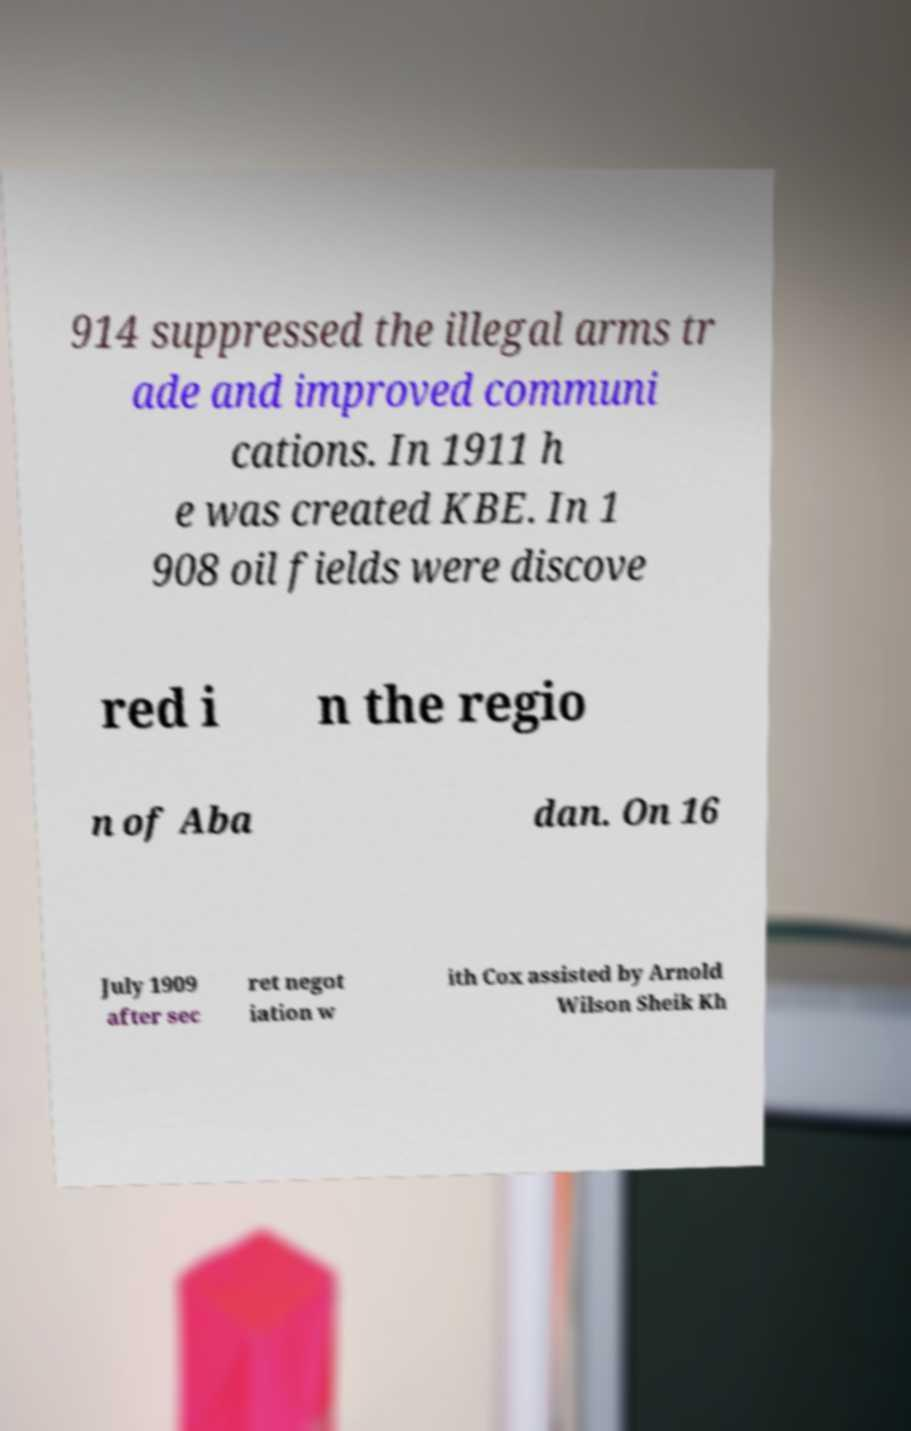Can you read and provide the text displayed in the image?This photo seems to have some interesting text. Can you extract and type it out for me? 914 suppressed the illegal arms tr ade and improved communi cations. In 1911 h e was created KBE. In 1 908 oil fields were discove red i n the regio n of Aba dan. On 16 July 1909 after sec ret negot iation w ith Cox assisted by Arnold Wilson Sheik Kh 